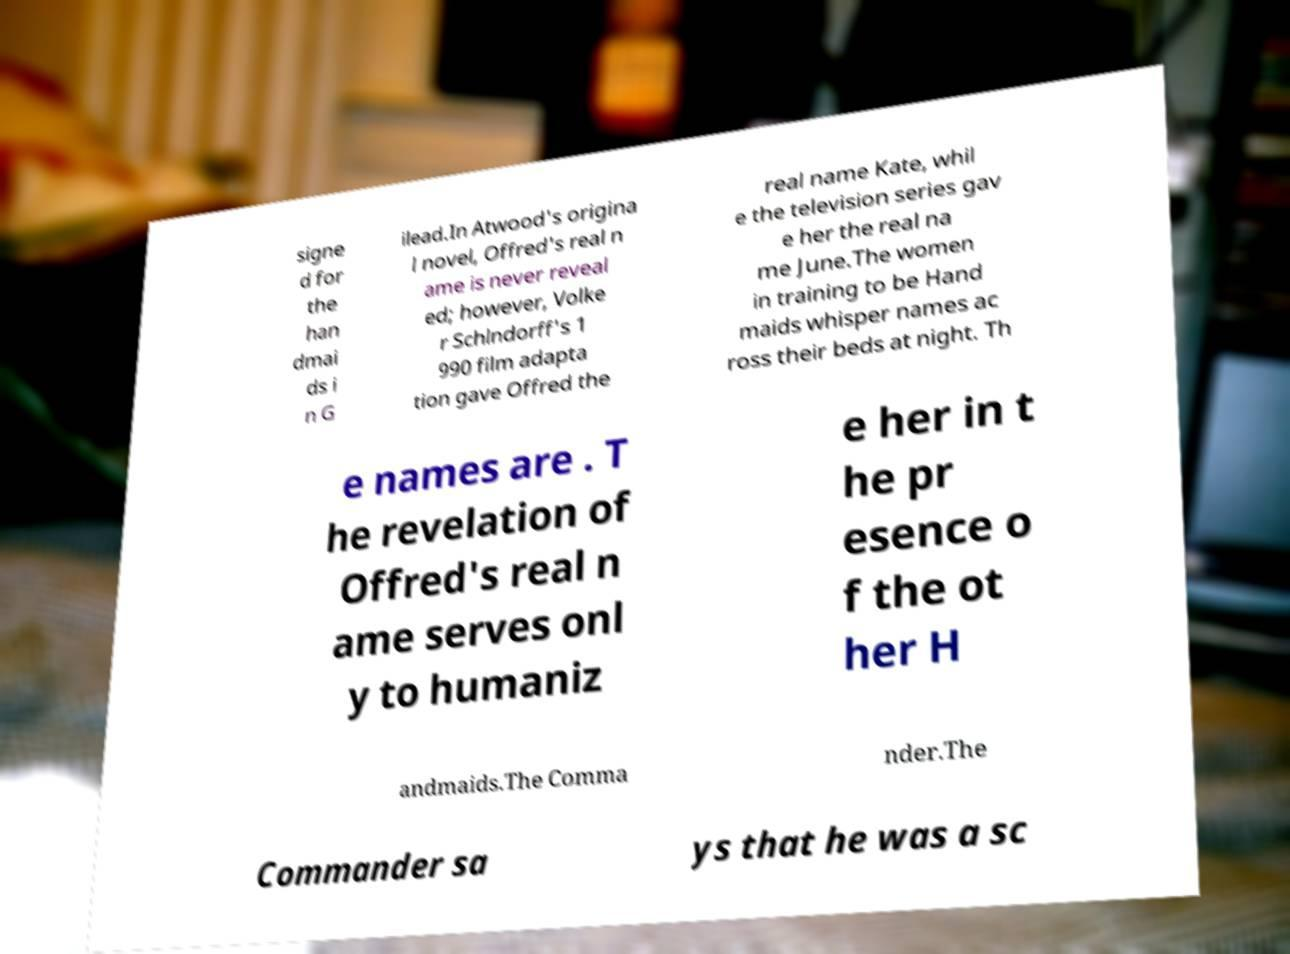Please read and relay the text visible in this image. What does it say? signe d for the han dmai ds i n G ilead.In Atwood's origina l novel, Offred's real n ame is never reveal ed; however, Volke r Schlndorff's 1 990 film adapta tion gave Offred the real name Kate, whil e the television series gav e her the real na me June.The women in training to be Hand maids whisper names ac ross their beds at night. Th e names are . T he revelation of Offred's real n ame serves onl y to humaniz e her in t he pr esence o f the ot her H andmaids.The Comma nder.The Commander sa ys that he was a sc 